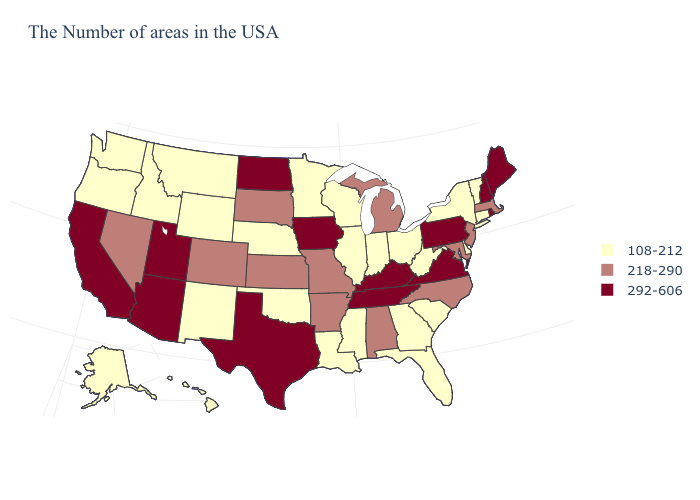What is the value of Idaho?
Give a very brief answer. 108-212. What is the value of Indiana?
Be succinct. 108-212. Which states hav the highest value in the South?
Write a very short answer. Virginia, Kentucky, Tennessee, Texas. Does North Dakota have the highest value in the USA?
Write a very short answer. Yes. Is the legend a continuous bar?
Keep it brief. No. What is the value of Massachusetts?
Concise answer only. 218-290. What is the highest value in the USA?
Write a very short answer. 292-606. Name the states that have a value in the range 108-212?
Answer briefly. Vermont, Connecticut, New York, Delaware, South Carolina, West Virginia, Ohio, Florida, Georgia, Indiana, Wisconsin, Illinois, Mississippi, Louisiana, Minnesota, Nebraska, Oklahoma, Wyoming, New Mexico, Montana, Idaho, Washington, Oregon, Alaska, Hawaii. What is the value of North Carolina?
Answer briefly. 218-290. Is the legend a continuous bar?
Answer briefly. No. What is the value of Virginia?
Short answer required. 292-606. What is the value of New York?
Write a very short answer. 108-212. Name the states that have a value in the range 218-290?
Be succinct. Massachusetts, New Jersey, Maryland, North Carolina, Michigan, Alabama, Missouri, Arkansas, Kansas, South Dakota, Colorado, Nevada. Does Tennessee have a higher value than North Dakota?
Quick response, please. No. What is the value of Florida?
Answer briefly. 108-212. 